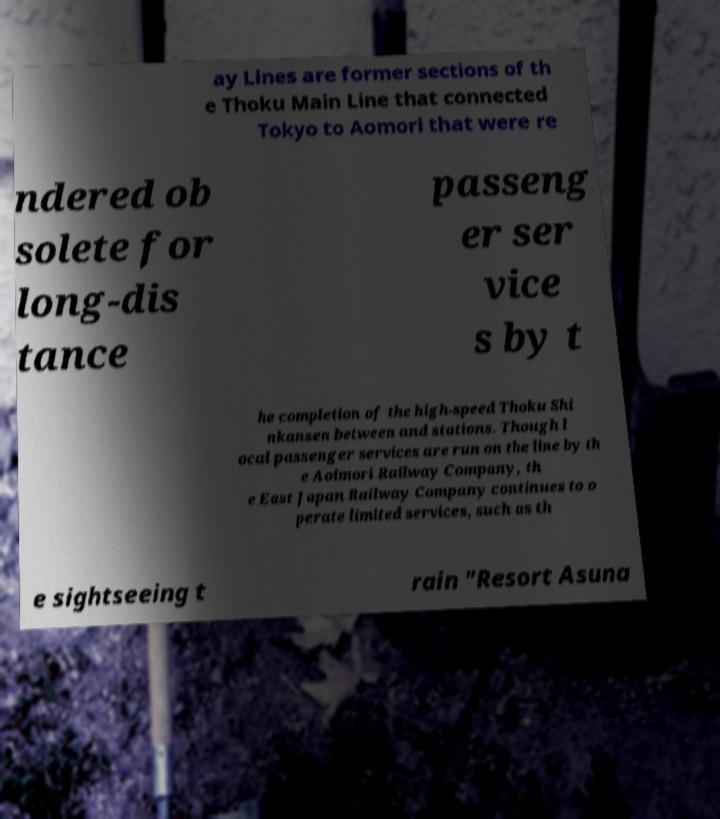For documentation purposes, I need the text within this image transcribed. Could you provide that? ay Lines are former sections of th e Thoku Main Line that connected Tokyo to Aomori that were re ndered ob solete for long-dis tance passeng er ser vice s by t he completion of the high-speed Thoku Shi nkansen between and stations. Though l ocal passenger services are run on the line by th e Aoimori Railway Company, th e East Japan Railway Company continues to o perate limited services, such as th e sightseeing t rain "Resort Asuna 